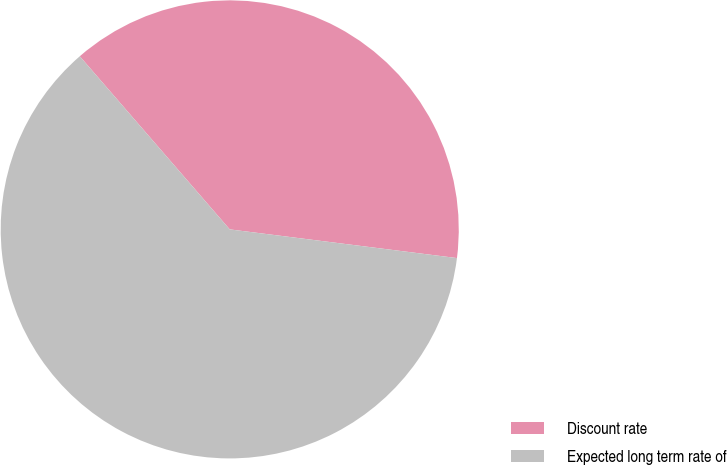Convert chart to OTSL. <chart><loc_0><loc_0><loc_500><loc_500><pie_chart><fcel>Discount rate<fcel>Expected long term rate of<nl><fcel>38.36%<fcel>61.64%<nl></chart> 